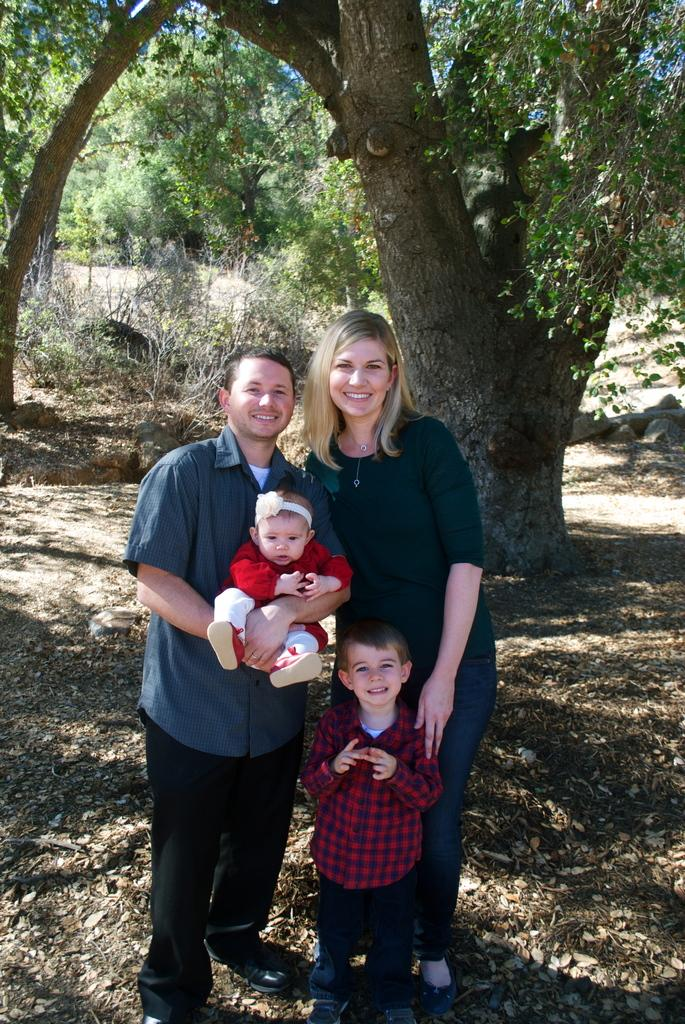How many people are in the image? There are three persons standing in the image. What is the person on the left doing? The person on the left is holding a baby. What can be seen in the background of the image? There are trees and the sky visible in the background of the image. What is the color of the trees in the image? The trees are green. What is the color of the sky in the image? The sky is blue. Can you tell me how many ladybugs are crawling on the faucet in the image? There are no ladybugs or faucets present in the image. What type of zebra can be seen in the background of the image? There is no zebra present in the image; only trees and the sky are visible in the background. 